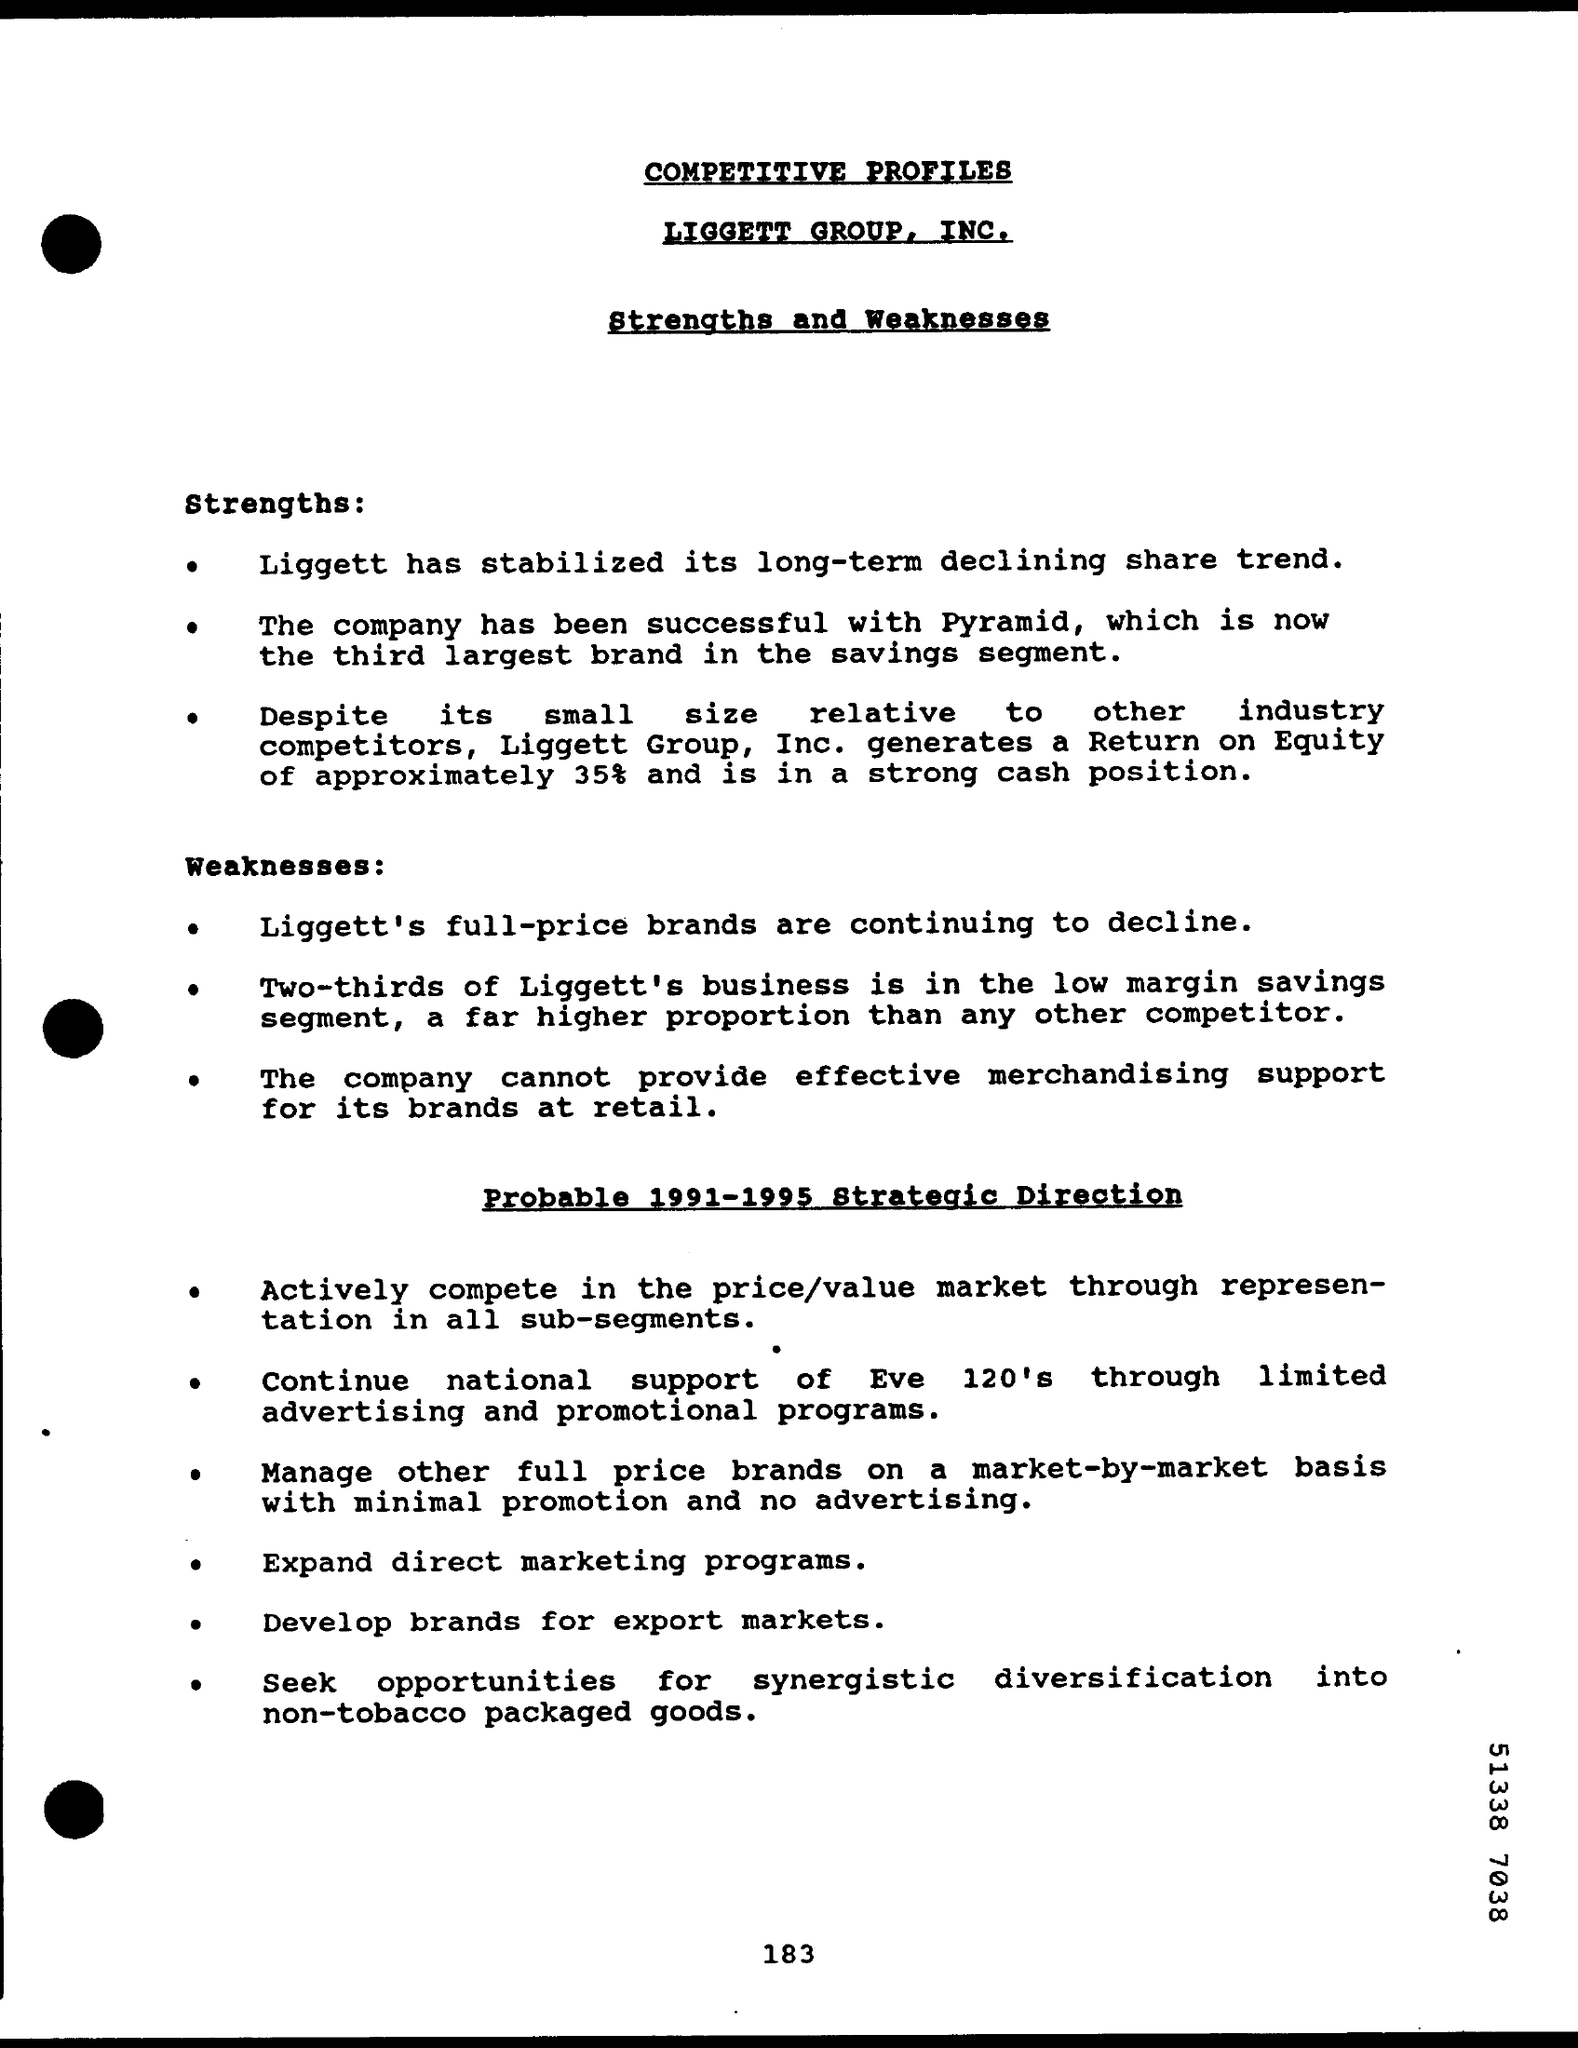Highlight a few significant elements in this photo. What is the first side heading given? Its strengths. The heading "LIGGETT GROUP, INC." highlights the importance of the section discussing the company's strengths and weaknesses. Pyramid, which is now the third largest brand in the savings segment, has seen significant growth in recent years. The page number given at the bottom of the page is 183. 